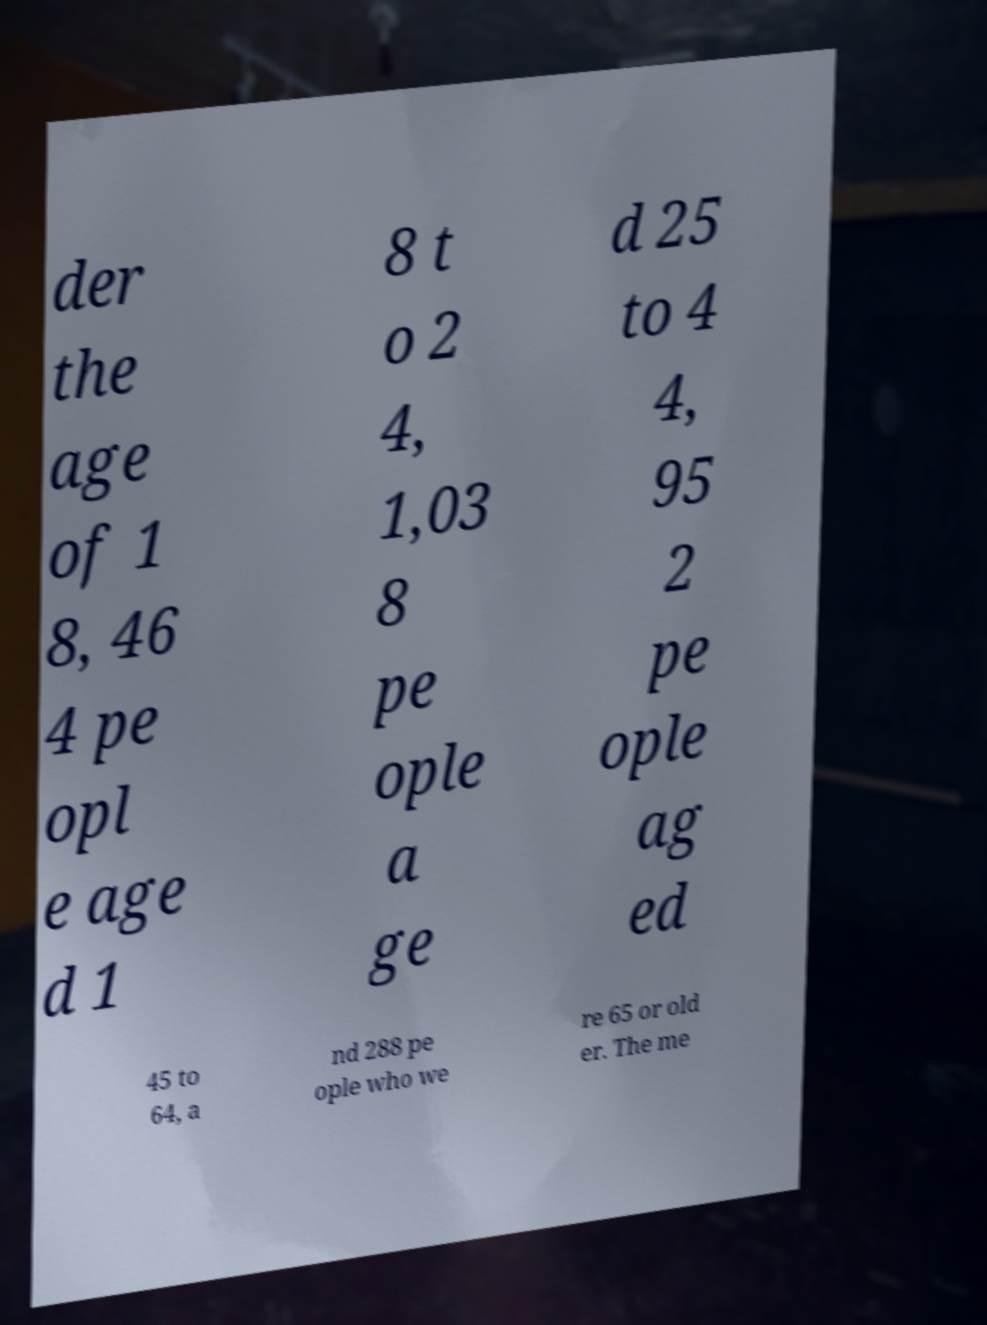Could you assist in decoding the text presented in this image and type it out clearly? der the age of 1 8, 46 4 pe opl e age d 1 8 t o 2 4, 1,03 8 pe ople a ge d 25 to 4 4, 95 2 pe ople ag ed 45 to 64, a nd 288 pe ople who we re 65 or old er. The me 